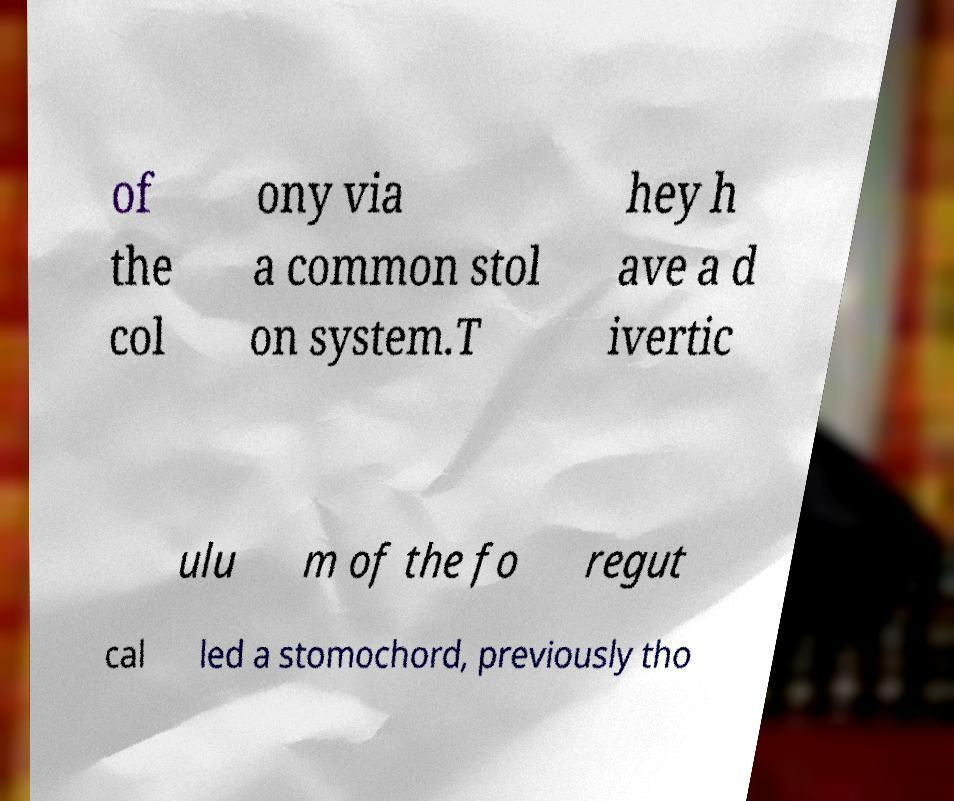Please identify and transcribe the text found in this image. of the col ony via a common stol on system.T hey h ave a d ivertic ulu m of the fo regut cal led a stomochord, previously tho 